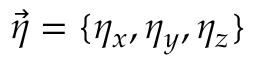Convert formula to latex. <formula><loc_0><loc_0><loc_500><loc_500>\vec { \eta } = \{ \eta _ { x } , \eta _ { y } , \eta _ { z } \}</formula> 